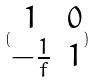Convert formula to latex. <formula><loc_0><loc_0><loc_500><loc_500>( \begin{matrix} 1 & 0 \\ - \frac { 1 } { f } & 1 \end{matrix} )</formula> 